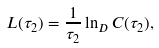Convert formula to latex. <formula><loc_0><loc_0><loc_500><loc_500>L ( \tau _ { 2 } ) = \frac { 1 } { \tau _ { 2 } } \ln _ { D } C ( \tau _ { 2 } ) ,</formula> 